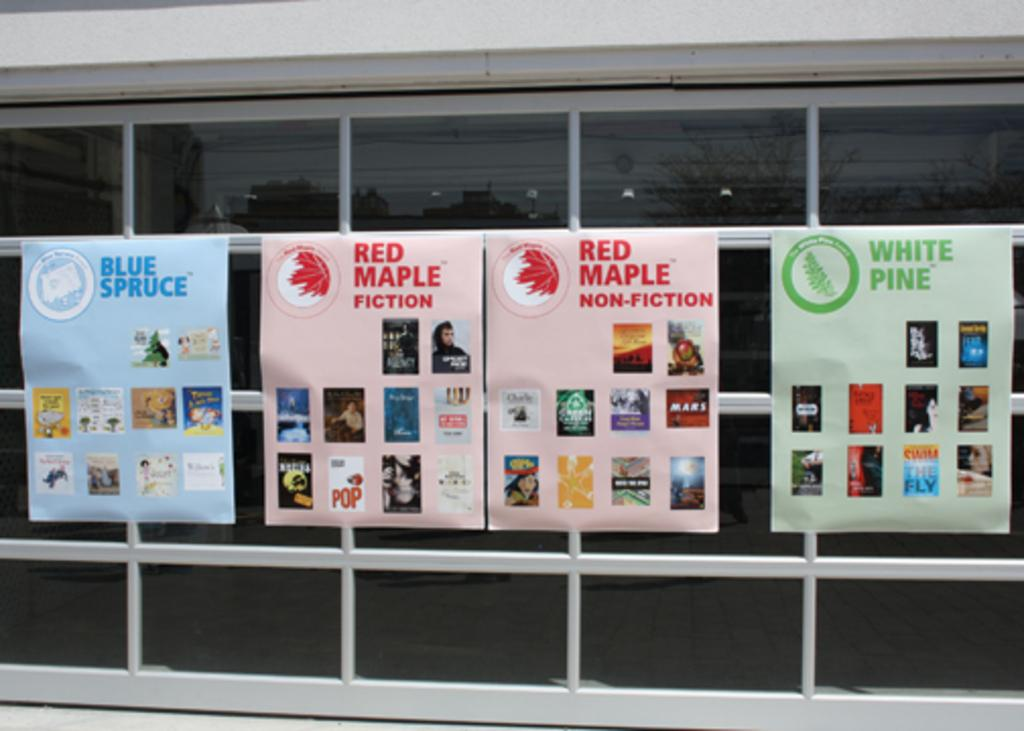What is attached to the glass door in the image? There are posters attached to the glass door. What can be seen in the reflection on the glass door? The reflection of trees and lights is visible in the glass door. What is located at the top of the image? There is a wall at the top of the image. In which direction is the ball bouncing in the image? There is no ball present in the image, so it is not possible to determine the direction in which it might be bouncing. 